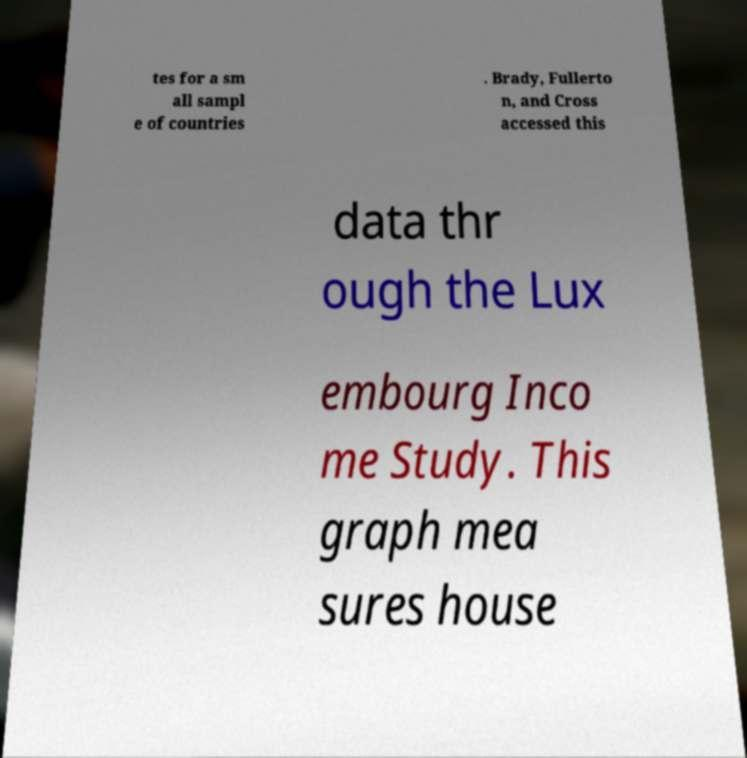What messages or text are displayed in this image? I need them in a readable, typed format. tes for a sm all sampl e of countries . Brady, Fullerto n, and Cross accessed this data thr ough the Lux embourg Inco me Study. This graph mea sures house 